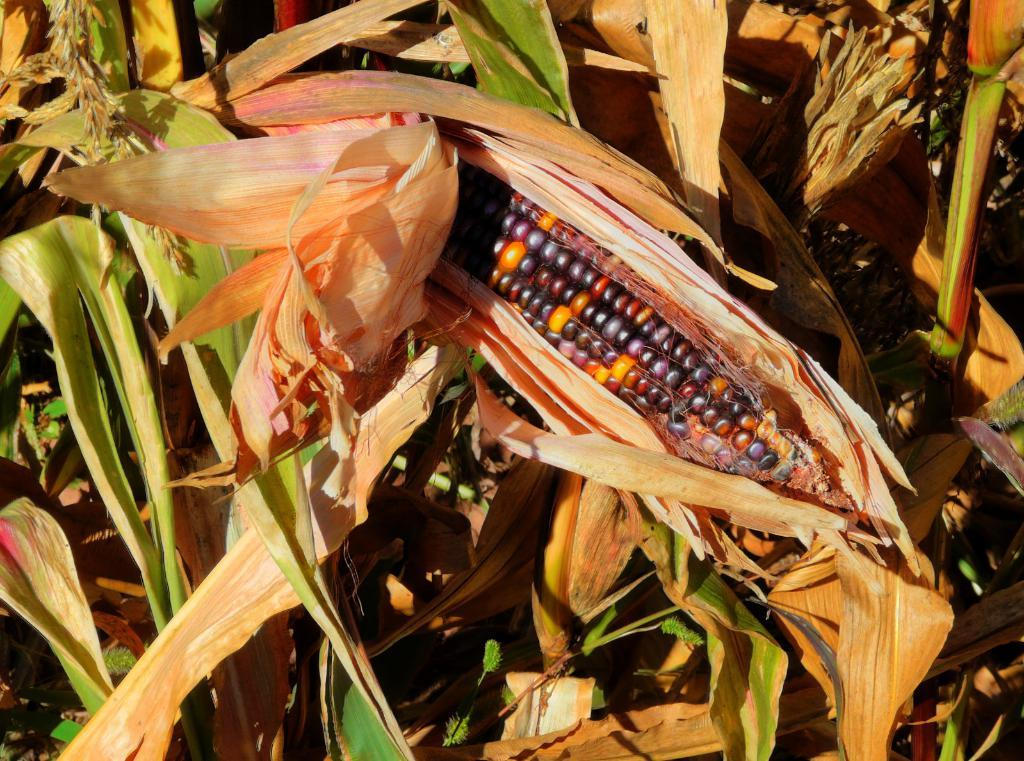What type of vegetation can be seen in the image? There are leaves in the image. What type of plant is also visible in the image? There is corn in the image. What colors are present on the corn? The corn has orange, black, and violet colors. Where is the hall located in the image? There is no hall present in the image. What type of hook can be seen attached to the corn? There are no hooks present in the image, and the corn is not attached to anything. 